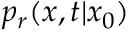Convert formula to latex. <formula><loc_0><loc_0><loc_500><loc_500>p _ { r } ( x , t | x _ { 0 } )</formula> 